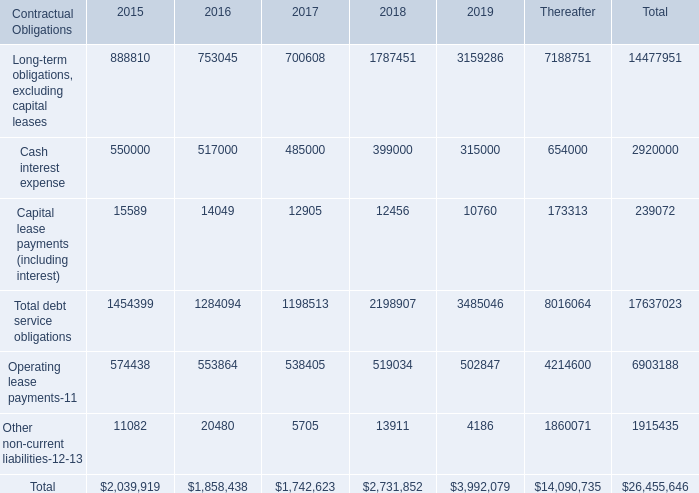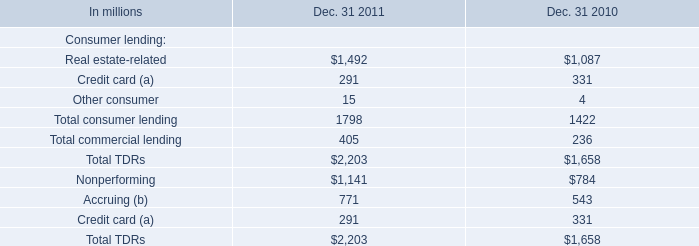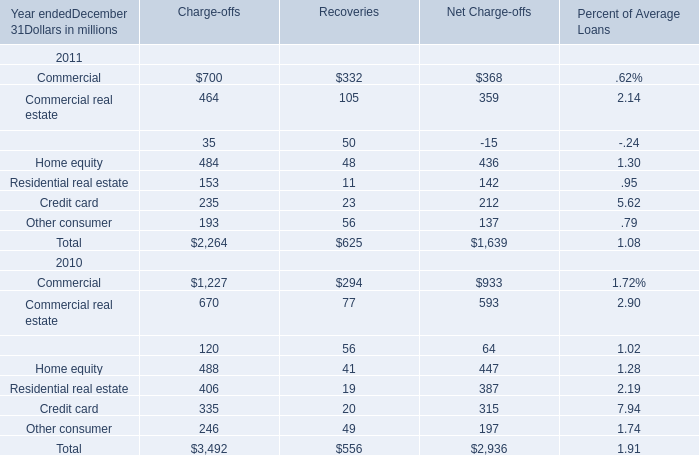In the year with the most Real estate-related, what is the growth rate of Other consumer? 
Computations: ((15 - 4) / 15)
Answer: 0.73333. 